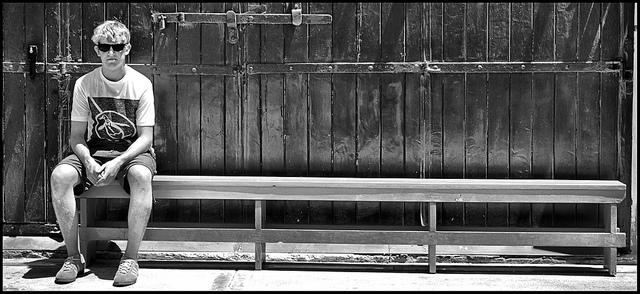What kind of glasses is he wearing?
Answer briefly. Sunglasses. Is this man resting?
Write a very short answer. Yes. Does the bench have a back?
Quick response, please. No. 